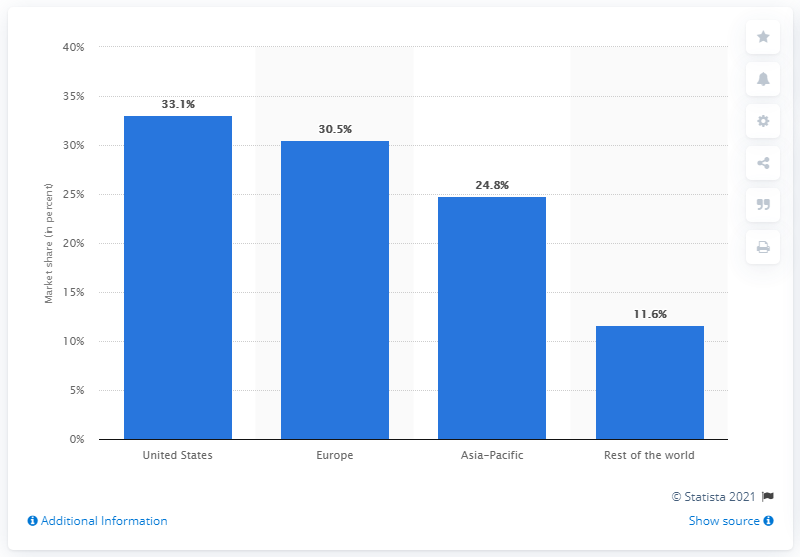Outline some significant characteristics in this image. In 2009, the Asia-Pacific region accounted for 24.8% of the total market revenues in the region. 